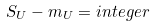<formula> <loc_0><loc_0><loc_500><loc_500>S _ { U } - m _ { U } = i n t e g e r</formula> 